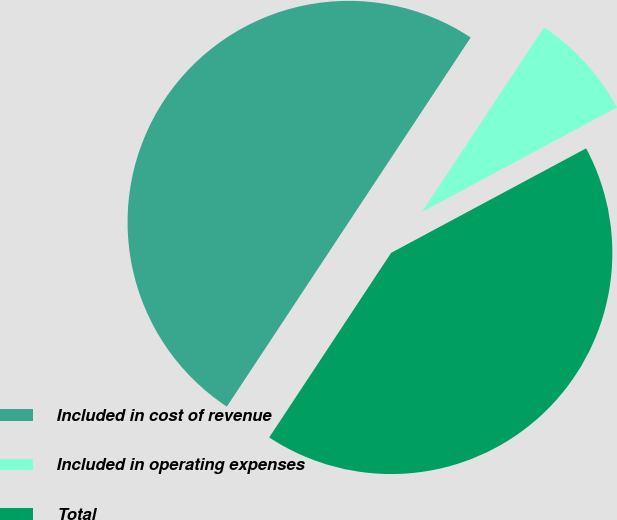Convert chart. <chart><loc_0><loc_0><loc_500><loc_500><pie_chart><fcel>Included in cost of revenue<fcel>Included in operating expenses<fcel>Total<nl><fcel>50.0%<fcel>7.88%<fcel>42.12%<nl></chart> 